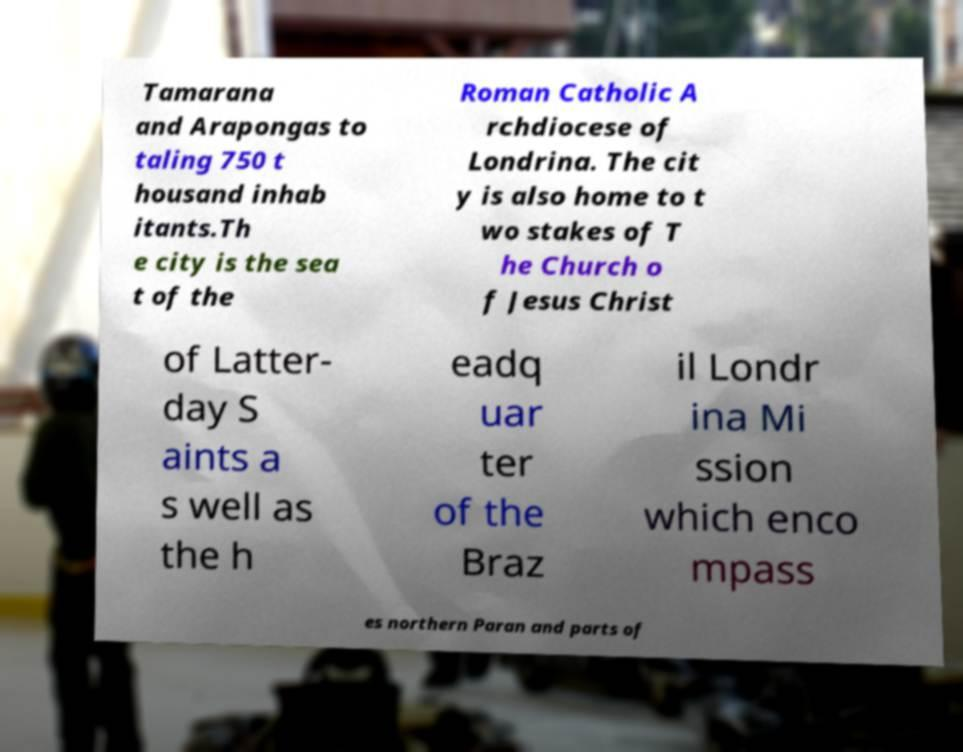Please identify and transcribe the text found in this image. Tamarana and Arapongas to taling 750 t housand inhab itants.Th e city is the sea t of the Roman Catholic A rchdiocese of Londrina. The cit y is also home to t wo stakes of T he Church o f Jesus Christ of Latter- day S aints a s well as the h eadq uar ter of the Braz il Londr ina Mi ssion which enco mpass es northern Paran and parts of 